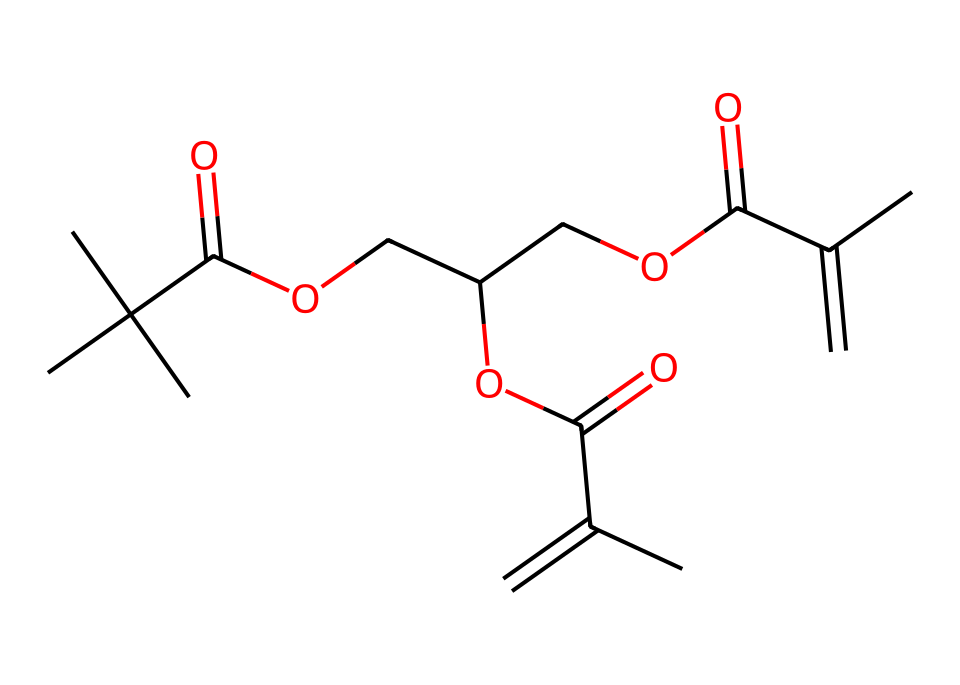How many carbon atoms are in this chemical structure? By analyzing the provided SMILES, we can count the number of carbon atoms represented. Each "C" in the SMILES indicates a carbon atom, and we can see that there are 16 occurrences of "C."
Answer: 16 What functional groups are present in this photoresist? The SMILES notation shows "C(=O)" which indicates the presence of carbonyl groups (part of carboxyl groups), and "OC" indicates ether groups. Therefore, this compound has carboxylic acid and ether functional groups.
Answer: carboxylic acid and ether What is the degree of unsaturation in this chemical? The degree of unsaturation can be calculated based on the number of rings and pi bonds in the structure. Each double bond counts as one degree of unsaturation. Analyzing the structure reveals several double bonds (alkene), indicating a degree of unsaturation of 3.
Answer: 3 What does the presence of the UV-sensitive part indicate about its use? The presence of the carbonyl (C=O) and alkene groups suggests the photoresist is designed to undergo photochemical reactions when exposed to UV light, which is essential in screen printing techniques for creating patterns.
Answer: photochemical reactions How many ester linkages are in this photoresist? By examining the structure, we can identify ester linkages by looking for the "C(=O)O" segments in the SMILES, indicating the presence of ester bonds. There are three such linkages identified in the chemical structure.
Answer: 3 What type of polymerization might this photoresist undergo? Given the presence of multiple functionalities such as carbonyls and alkenes, this photoresist likely undergoes cross-linking reactions during UV exposure, which is characteristic of step-growth polymerization processes.
Answer: cross-linking reactions 